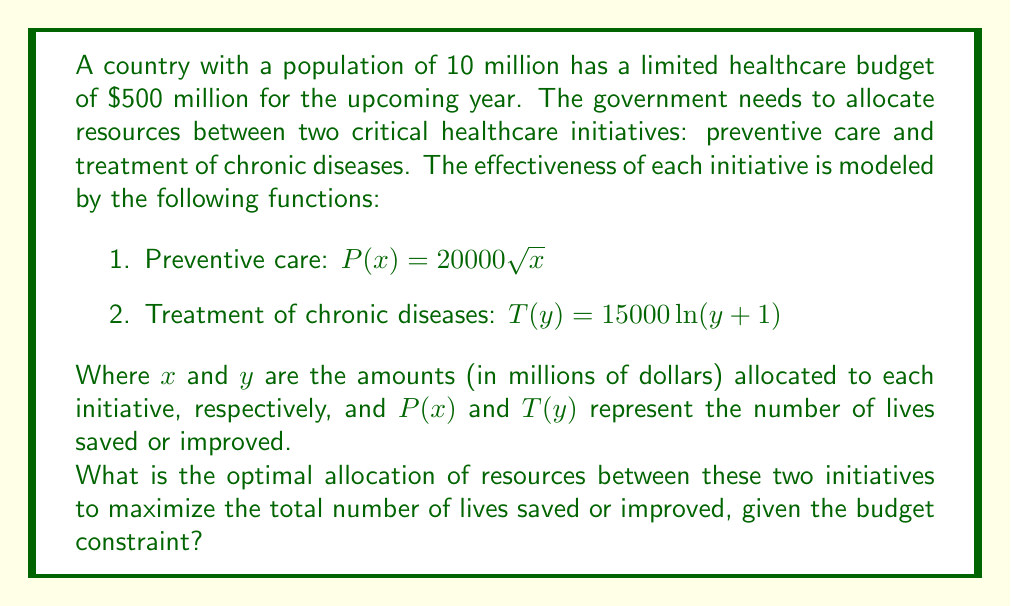Show me your answer to this math problem. To solve this optimization problem, we can use the method of Lagrange multipliers. Let's follow these steps:

1. Define the objective function:
   $f(x,y) = P(x) + T(y) = 20000\sqrt{x} + 15000\ln(y+1)$

2. Define the constraint:
   $g(x,y) = x + y - 500 = 0$

3. Form the Lagrangian:
   $L(x,y,\lambda) = f(x,y) - \lambda g(x,y)$
   $L(x,y,\lambda) = 20000\sqrt{x} + 15000\ln(y+1) - \lambda(x + y - 500)$

4. Take partial derivatives and set them to zero:
   $\frac{\partial L}{\partial x} = \frac{10000}{\sqrt{x}} - \lambda = 0$
   $\frac{\partial L}{\partial y} = \frac{15000}{y+1} - \lambda = 0$
   $\frac{\partial L}{\partial \lambda} = x + y - 500 = 0$

5. From the first two equations:
   $\frac{10000}{\sqrt{x}} = \frac{15000}{y+1}$

6. Simplify:
   $15000\sqrt{x} = 10000(y+1)$
   $\frac{9}{4}x = (y+1)^2$

7. Substitute into the constraint equation:
   $x + (\frac{3}{2}\sqrt{x} - 1) = 500$

8. Solve this equation numerically (e.g., using Newton's method) to get:
   $x \approx 277.78$

9. Substitute back to find y:
   $y = 500 - x \approx 222.22$

10. Round to the nearest million for practical implementation.

Therefore, the optimal allocation is approximately $278 million for preventive care and $222 million for treatment of chronic diseases.
Answer: Optimal allocation: $278 million for preventive care, $222 million for treatment of chronic diseases. 